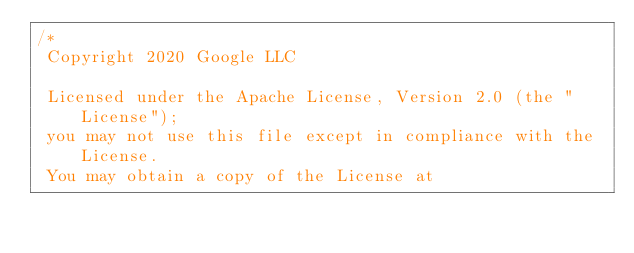Convert code to text. <code><loc_0><loc_0><loc_500><loc_500><_C_>/*
 Copyright 2020 Google LLC

 Licensed under the Apache License, Version 2.0 (the "License");
 you may not use this file except in compliance with the License.
 You may obtain a copy of the License at
</code> 